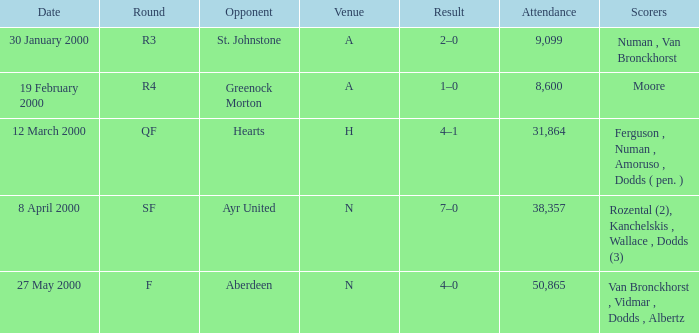Who was in a with rival st. johnstone? Numan , Van Bronckhorst. 